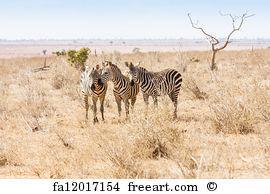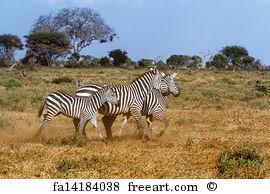The first image is the image on the left, the second image is the image on the right. Assess this claim about the two images: "In the right image, three zebras are heading right.". Correct or not? Answer yes or no. Yes. The first image is the image on the left, the second image is the image on the right. Assess this claim about the two images: "Each image contains exactly three zebras, and no zebras are standing with their rears facing the camera.". Correct or not? Answer yes or no. Yes. 